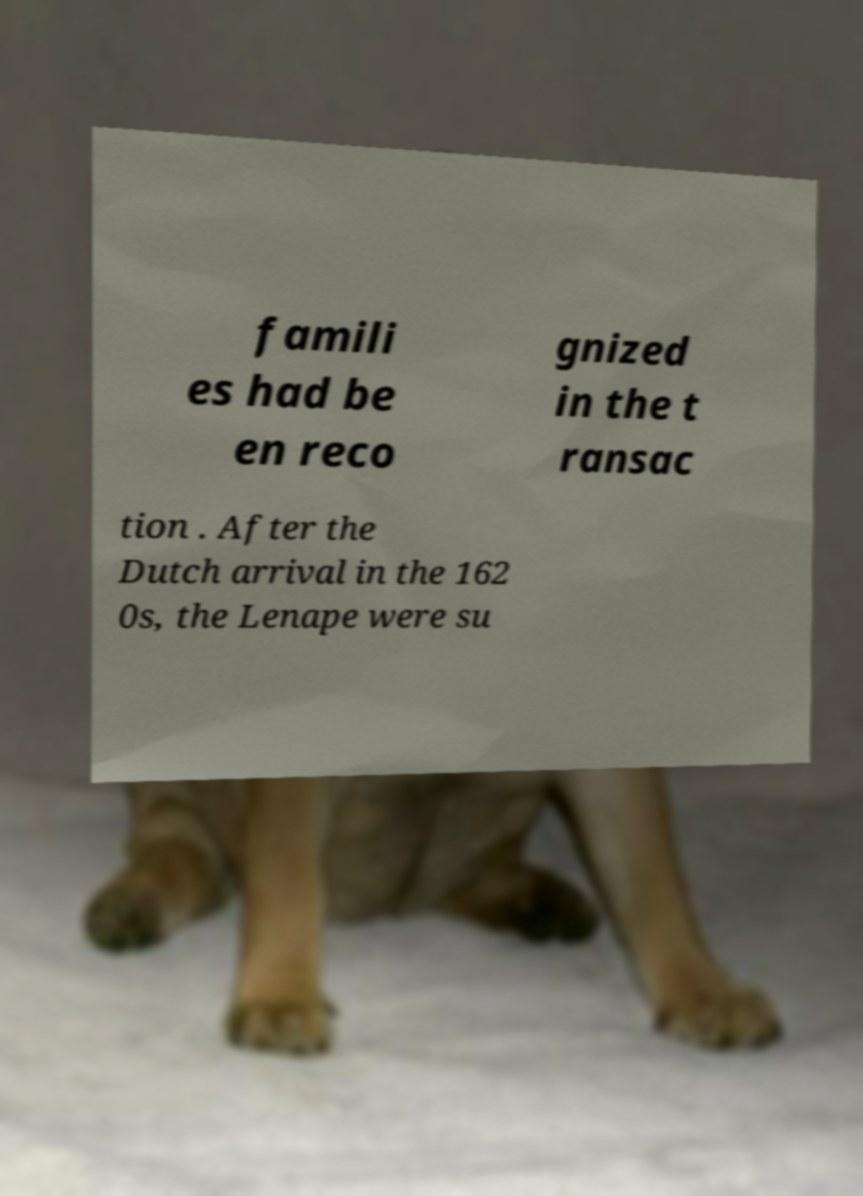Can you accurately transcribe the text from the provided image for me? famili es had be en reco gnized in the t ransac tion . After the Dutch arrival in the 162 0s, the Lenape were su 